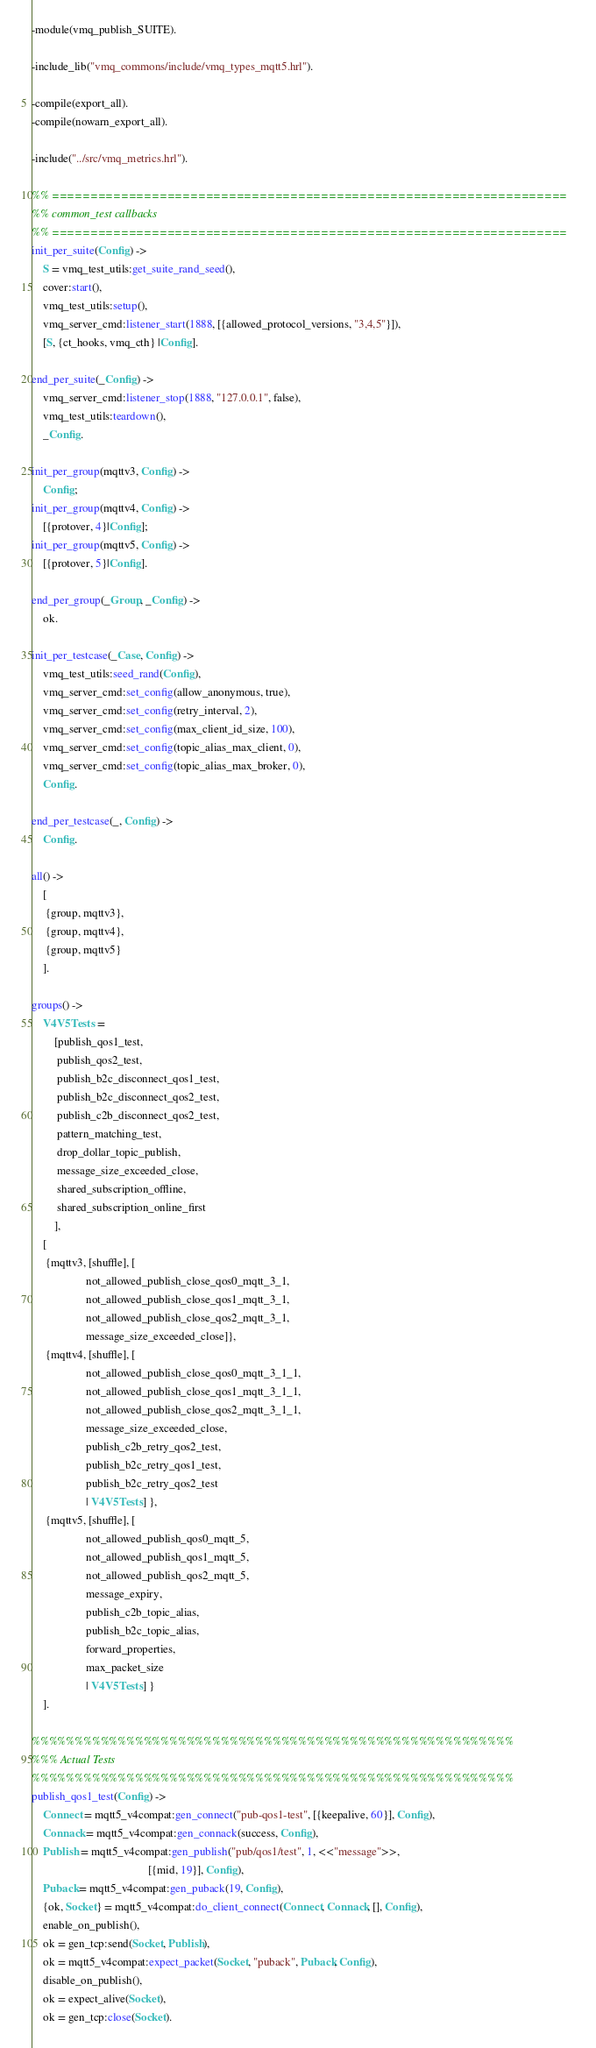Convert code to text. <code><loc_0><loc_0><loc_500><loc_500><_Erlang_>-module(vmq_publish_SUITE).

-include_lib("vmq_commons/include/vmq_types_mqtt5.hrl").

-compile(export_all).
-compile(nowarn_export_all).

-include("../src/vmq_metrics.hrl").

%% ===================================================================
%% common_test callbacks
%% ===================================================================
init_per_suite(Config) ->
    S = vmq_test_utils:get_suite_rand_seed(),
    cover:start(),
    vmq_test_utils:setup(),
    vmq_server_cmd:listener_start(1888, [{allowed_protocol_versions, "3,4,5"}]),
    [S, {ct_hooks, vmq_cth} |Config].

end_per_suite(_Config) ->
    vmq_server_cmd:listener_stop(1888, "127.0.0.1", false),
    vmq_test_utils:teardown(),
    _Config.

init_per_group(mqttv3, Config) ->
    Config;
init_per_group(mqttv4, Config) ->
    [{protover, 4}|Config];
init_per_group(mqttv5, Config) ->
    [{protover, 5}|Config].

end_per_group(_Group, _Config) ->
    ok.

init_per_testcase(_Case, Config) ->
    vmq_test_utils:seed_rand(Config),
    vmq_server_cmd:set_config(allow_anonymous, true),
    vmq_server_cmd:set_config(retry_interval, 2),
    vmq_server_cmd:set_config(max_client_id_size, 100),
    vmq_server_cmd:set_config(topic_alias_max_client, 0),
    vmq_server_cmd:set_config(topic_alias_max_broker, 0),
    Config.

end_per_testcase(_, Config) ->
    Config.

all() ->
    [
     {group, mqttv3},
     {group, mqttv4},
     {group, mqttv5}
    ].

groups() ->
    V4V5Tests =
        [publish_qos1_test,
         publish_qos2_test,
         publish_b2c_disconnect_qos1_test,
         publish_b2c_disconnect_qos2_test,
         publish_c2b_disconnect_qos2_test,
         pattern_matching_test,
         drop_dollar_topic_publish,
         message_size_exceeded_close,
         shared_subscription_offline,
         shared_subscription_online_first
        ],
    [
     {mqttv3, [shuffle], [
                   not_allowed_publish_close_qos0_mqtt_3_1,
                   not_allowed_publish_close_qos1_mqtt_3_1,
                   not_allowed_publish_close_qos2_mqtt_3_1,
                   message_size_exceeded_close]},
     {mqttv4, [shuffle], [
                   not_allowed_publish_close_qos0_mqtt_3_1_1,
                   not_allowed_publish_close_qos1_mqtt_3_1_1,
                   not_allowed_publish_close_qos2_mqtt_3_1_1,
                   message_size_exceeded_close,
                   publish_c2b_retry_qos2_test,
                   publish_b2c_retry_qos1_test,
                   publish_b2c_retry_qos2_test
                   | V4V5Tests] },
     {mqttv5, [shuffle], [
                   not_allowed_publish_qos0_mqtt_5,
                   not_allowed_publish_qos1_mqtt_5,
                   not_allowed_publish_qos2_mqtt_5,
                   message_expiry,
                   publish_c2b_topic_alias,
                   publish_b2c_topic_alias,
                   forward_properties,
                   max_packet_size
                   | V4V5Tests] }
    ].

%%%%%%%%%%%%%%%%%%%%%%%%%%%%%%%%%%%%%%%%%%%%%%%%%%%%%%%%
%%% Actual Tests
%%%%%%%%%%%%%%%%%%%%%%%%%%%%%%%%%%%%%%%%%%%%%%%%%%%%%%%%
publish_qos1_test(Config) ->
    Connect = mqtt5_v4compat:gen_connect("pub-qos1-test", [{keepalive, 60}], Config),
    Connack = mqtt5_v4compat:gen_connack(success, Config),
    Publish = mqtt5_v4compat:gen_publish("pub/qos1/test", 1, <<"message">>,
                                         [{mid, 19}], Config),
    Puback = mqtt5_v4compat:gen_puback(19, Config),
    {ok, Socket} = mqtt5_v4compat:do_client_connect(Connect, Connack, [], Config),
    enable_on_publish(),
    ok = gen_tcp:send(Socket, Publish),
    ok = mqtt5_v4compat:expect_packet(Socket, "puback", Puback, Config),
    disable_on_publish(),
    ok = expect_alive(Socket),
    ok = gen_tcp:close(Socket).
</code> 